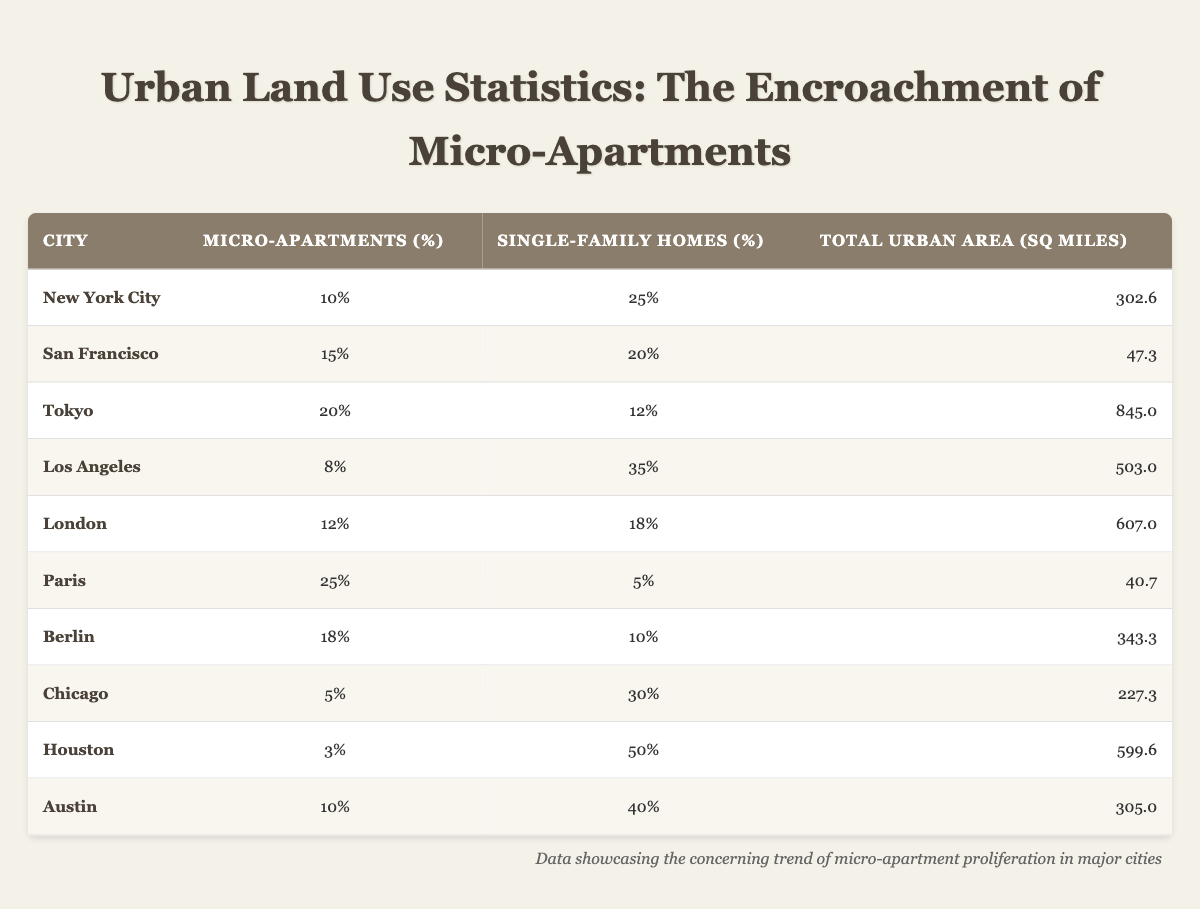What percentage of urban area in San Francisco is dedicated to single-family homes? In the table, find the row for San Francisco. The column titled "Single-Family Homes (%)" shows that the percentage is 20%.
Answer: 20% Which city has the highest percentage of micro-apartments? By examining the "Micro-Apartments (%)" column, we can see that Paris has the highest percentage with 25%.
Answer: Paris What is the difference between the percentage of micro-apartments and single-family homes in New York City? For New York City, the percentage of micro-apartments is 10%, and the percentage of single-family homes is 25%. The difference is 25% - 10% = 15%.
Answer: 15% True or False: Chicago has more than 10% of its urban area dedicated to micro-apartments. In the table, the percentage for Chicago is 5%, which is less than 10%. Therefore, the statement is False.
Answer: False What is the average percentage of micro-apartments across all cities listed? To find the average, sum the percentages in the "Micro-Apartments (%)" column: 10 + 15 + 20 + 8 + 12 + 25 + 18 + 5 + 3 + 10 = 126. Since there are 10 cities, divide 126 by 10, yielding an average of 12.6%.
Answer: 12.6% Which city has the least amount of urban area yet has a higher percentage of micro-apartments than Los Angeles? Los Angeles has a percentage of micro-apartments at 8%. The only city with less urban area and a higher percentage is San Francisco, which has 15% and an urban area of 47.3 square miles.
Answer: San Francisco What is the total percentage of single-family homes in Tokyo and Berlin combined? The percentage of single-family homes in Tokyo is 12%, and in Berlin, it is 10%. Adding these gives 12% + 10% = 22%.
Answer: 22% In which city is the percentage of micro-apartments and single-family homes equal to 30% or more combined? To find this, examine the total of both percentages for each city. Los Angeles (8% + 35% = 43%), New York City (10% + 25% = 35%), and Chicago (5% + 30% = 35%) satisfy this condition. However, Houston (3% + 50% = 53%) also qualifies. The cities with totals of 30% or more combined are Los Angeles, New York City, Chicago, and Houston.
Answer: Los Angeles, New York City, Chicago, Houston What percentage of urban area dedicated to micro-apartments indicates a trend of diminishing single-family homes in urban planning? Observing the table, cities like Paris (25%) with very low single-family homes (5%) illustrate this trend, indicating a significant shift towards micro-apartments. Generally, a micro-apartment percentage above 20% could suggest diminishing traditional housing options.
Answer: 25% in Paris 